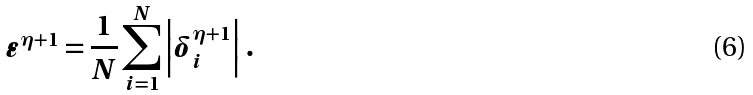<formula> <loc_0><loc_0><loc_500><loc_500>\varepsilon ^ { \eta + 1 } = \frac { 1 } { N } \sum ^ { N } _ { i = 1 } \left | \delta ^ { \eta + 1 } _ { i } \right | \, .</formula> 